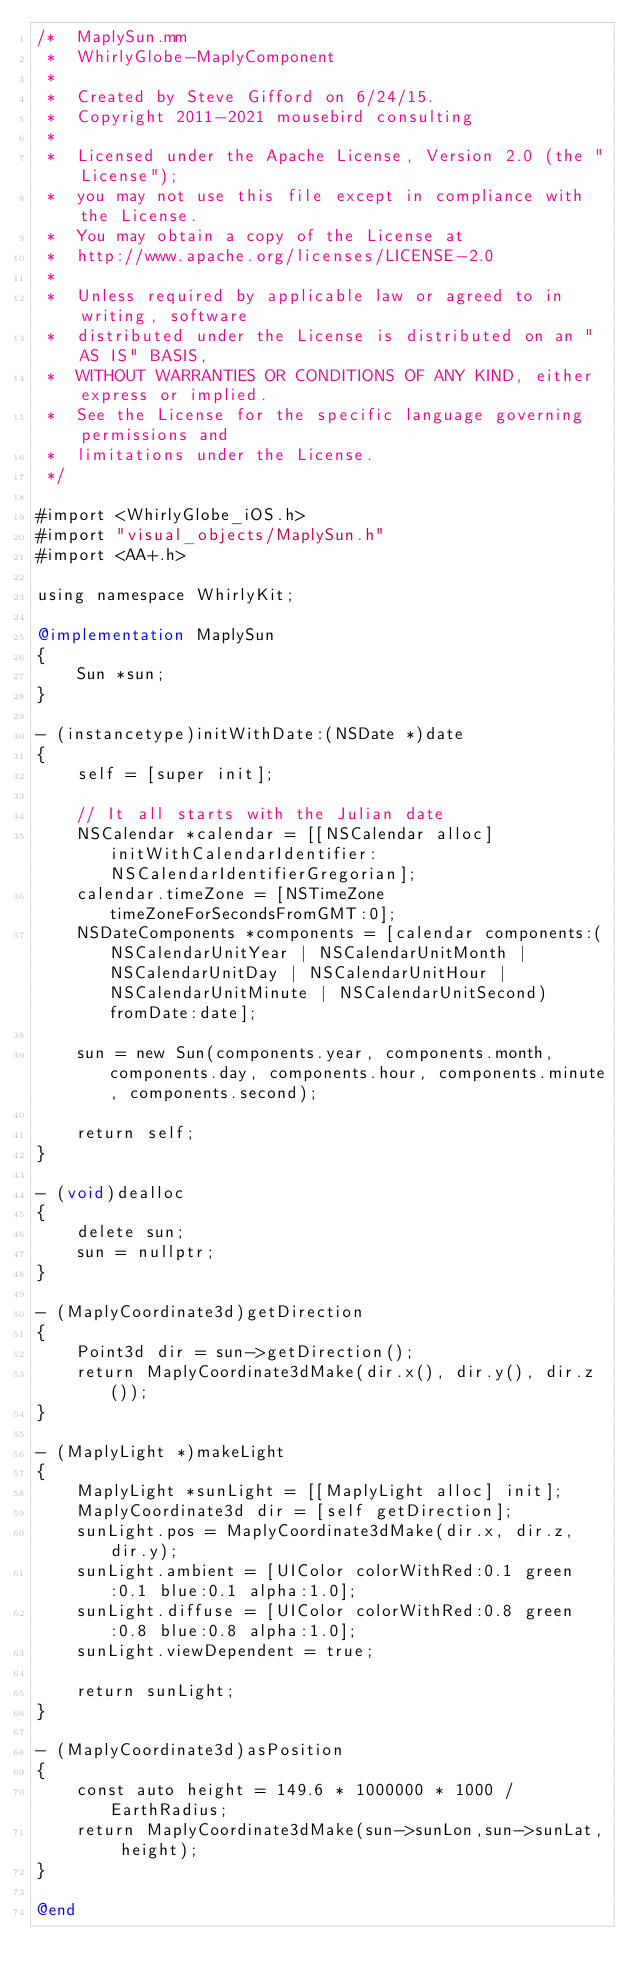<code> <loc_0><loc_0><loc_500><loc_500><_ObjectiveC_>/*  MaplySun.mm
 *  WhirlyGlobe-MaplyComponent
 *
 *  Created by Steve Gifford on 6/24/15.
 *  Copyright 2011-2021 mousebird consulting
 *
 *  Licensed under the Apache License, Version 2.0 (the "License");
 *  you may not use this file except in compliance with the License.
 *  You may obtain a copy of the License at
 *  http://www.apache.org/licenses/LICENSE-2.0
 *
 *  Unless required by applicable law or agreed to in writing, software
 *  distributed under the License is distributed on an "AS IS" BASIS,
 *  WITHOUT WARRANTIES OR CONDITIONS OF ANY KIND, either express or implied.
 *  See the License for the specific language governing permissions and
 *  limitations under the License.
 */

#import <WhirlyGlobe_iOS.h>
#import "visual_objects/MaplySun.h"
#import <AA+.h>

using namespace WhirlyKit;

@implementation MaplySun
{
    Sun *sun;
}

- (instancetype)initWithDate:(NSDate *)date
{
    self = [super init];
    
    // It all starts with the Julian date
    NSCalendar *calendar = [[NSCalendar alloc] initWithCalendarIdentifier:NSCalendarIdentifierGregorian];
    calendar.timeZone = [NSTimeZone timeZoneForSecondsFromGMT:0];
    NSDateComponents *components = [calendar components:(NSCalendarUnitYear | NSCalendarUnitMonth | NSCalendarUnitDay | NSCalendarUnitHour | NSCalendarUnitMinute | NSCalendarUnitSecond) fromDate:date];

    sun = new Sun(components.year, components.month, components.day, components.hour, components.minute, components.second);
    
    return self;
}

- (void)dealloc
{
    delete sun;
    sun = nullptr;
}

- (MaplyCoordinate3d)getDirection
{
    Point3d dir = sun->getDirection();
    return MaplyCoordinate3dMake(dir.x(), dir.y(), dir.z());
}

- (MaplyLight *)makeLight
{
    MaplyLight *sunLight = [[MaplyLight alloc] init];
    MaplyCoordinate3d dir = [self getDirection];
    sunLight.pos = MaplyCoordinate3dMake(dir.x, dir.z, dir.y);
    sunLight.ambient = [UIColor colorWithRed:0.1 green:0.1 blue:0.1 alpha:1.0];
    sunLight.diffuse = [UIColor colorWithRed:0.8 green:0.8 blue:0.8 alpha:1.0];
    sunLight.viewDependent = true;
    
    return sunLight;
}

- (MaplyCoordinate3d)asPosition
{
    const auto height = 149.6 * 1000000 * 1000 / EarthRadius;
    return MaplyCoordinate3dMake(sun->sunLon,sun->sunLat, height);
}

@end
</code> 